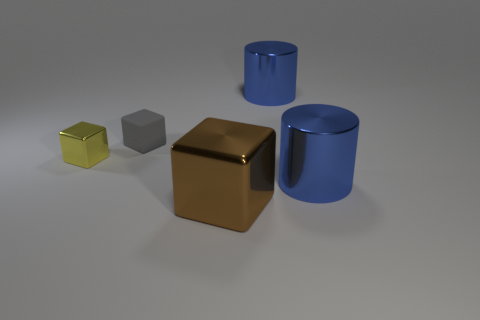Add 4 gray rubber cubes. How many objects exist? 9 Subtract all cylinders. How many objects are left? 3 Add 4 blue things. How many blue things exist? 6 Subtract 1 gray blocks. How many objects are left? 4 Subtract all small matte things. Subtract all large brown shiny objects. How many objects are left? 3 Add 1 blue shiny cylinders. How many blue shiny cylinders are left? 3 